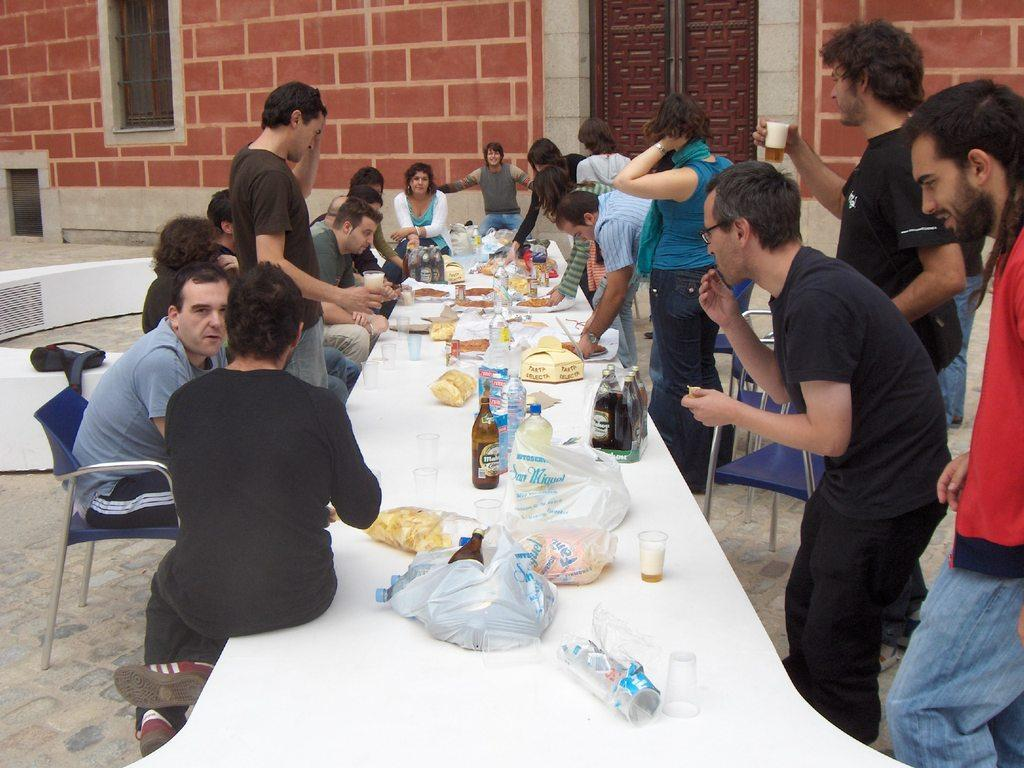What are the people in the image doing? The people in the image are sitting and standing around a table. What objects can be seen on the table? There are bottles, plates, and food items on the table. What type of honey is being served in the image? There is no honey present in the image. What fictional character can be seen interacting with the people at the table? There are no fictional characters present in the image. 